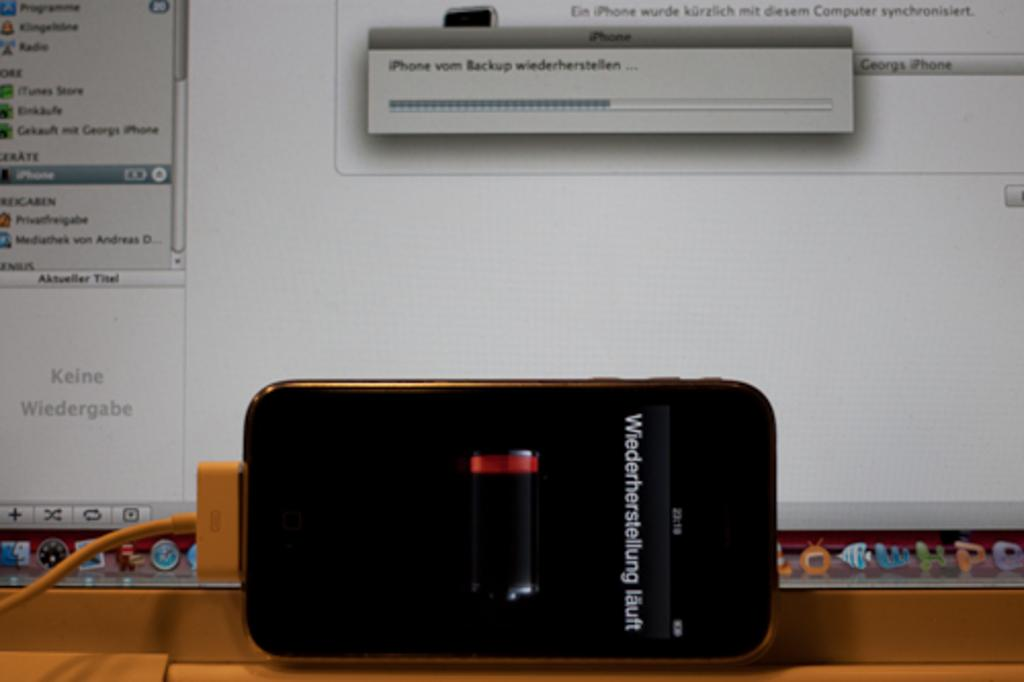<image>
Describe the image concisely. a cell phone is being charged displaying Wiederherstellung läuft 